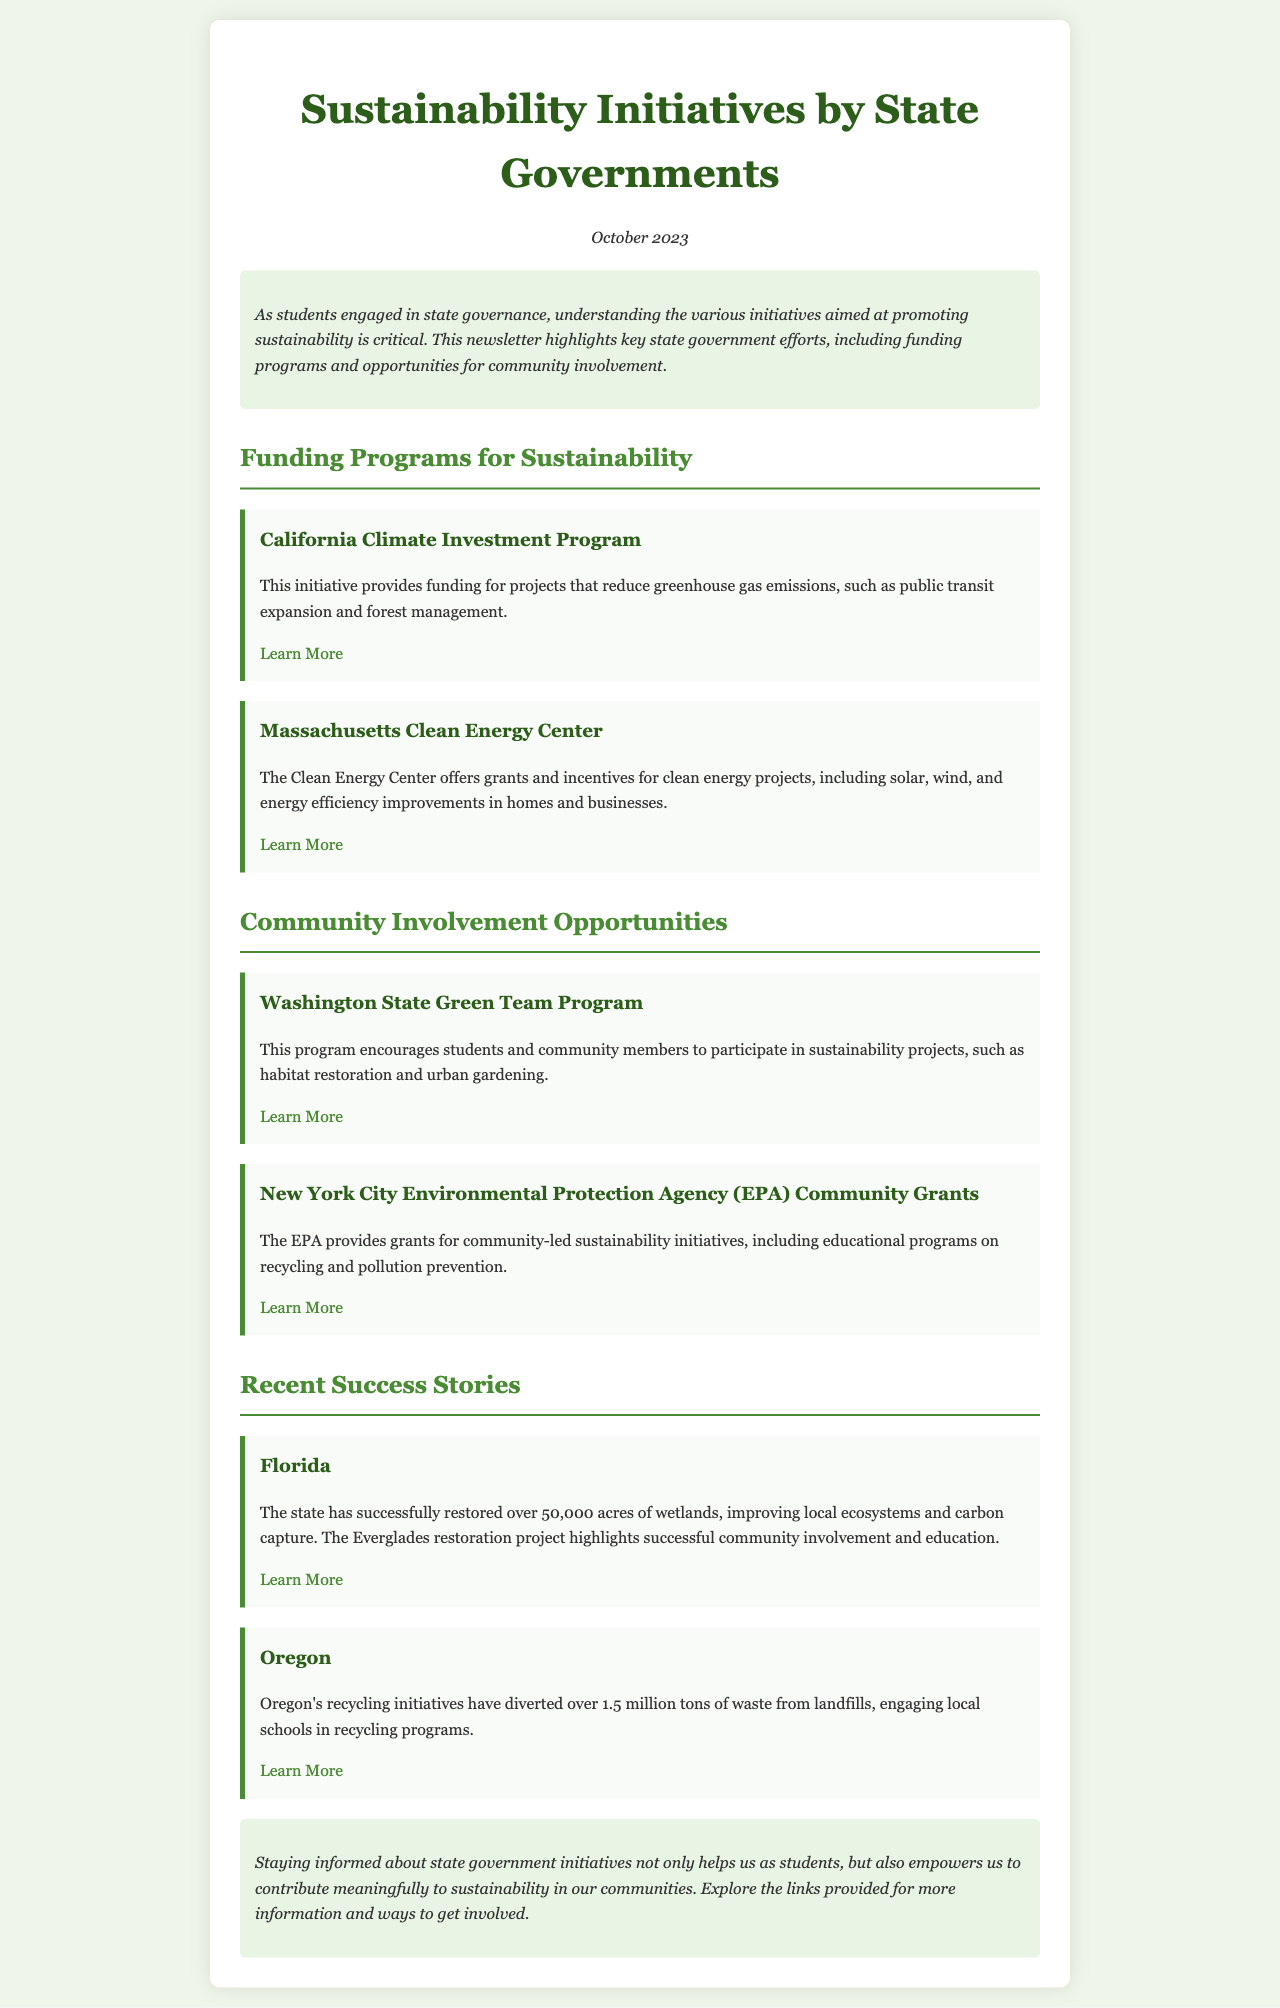What is the date of the newsletter? The date is clearly mentioned in the document, stating "October 2023."
Answer: October 2023 What initiative does California have for climate investment? The document mentions the "California Climate Investment Program" as an initiative for climate investment.
Answer: California Climate Investment Program How many acres of wetlands has Florida successfully restored? According to the success stories, Florida has restored "over 50,000 acres" of wetlands.
Answer: over 50,000 acres What is the primary purpose of Massachusetts Clean Energy Center? The Clean Energy Center's primary purpose is mentioned as providing grants and incentives for "clean energy projects."
Answer: clean energy projects What type of projects does the Washington State Green Team Program encourage? The program encourages participation in sustainability projects such as "habitat restoration" and "urban gardening."
Answer: habitat restoration and urban gardening Which state's recycling initiatives diverted over 1.5 million tons of waste? The document states that "Oregon's recycling initiatives" diverted this amount of waste.
Answer: Oregon What are the two areas of focus for the New York City EPA Community Grants? The grants focus on "educational programs on recycling and pollution prevention."
Answer: educational programs on recycling and pollution prevention What type of content does the document provide links to for more information? The document provides links related to "state government initiatives" and community involvement opportunities.
Answer: state government initiatives and community involvement opportunities 